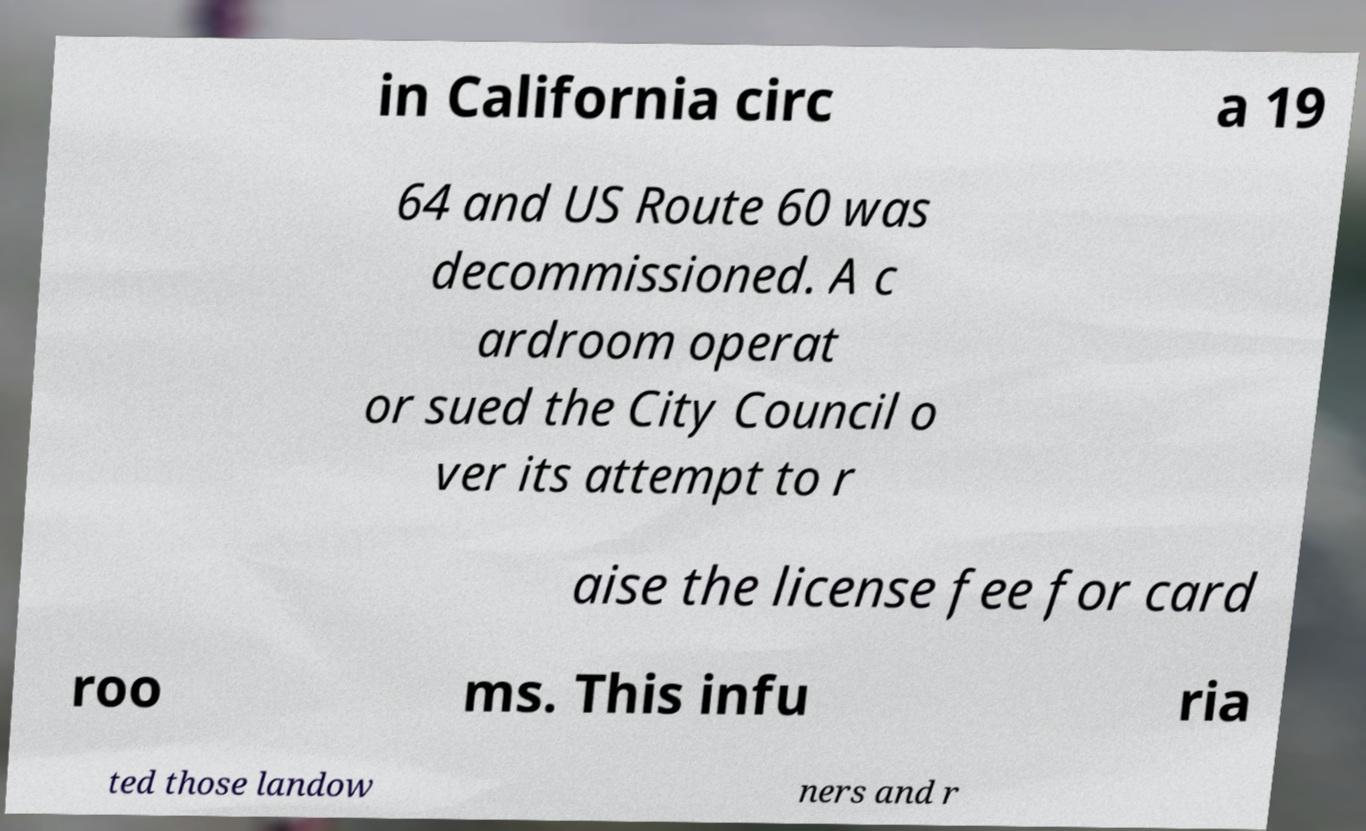Please read and relay the text visible in this image. What does it say? in California circ a 19 64 and US Route 60 was decommissioned. A c ardroom operat or sued the City Council o ver its attempt to r aise the license fee for card roo ms. This infu ria ted those landow ners and r 